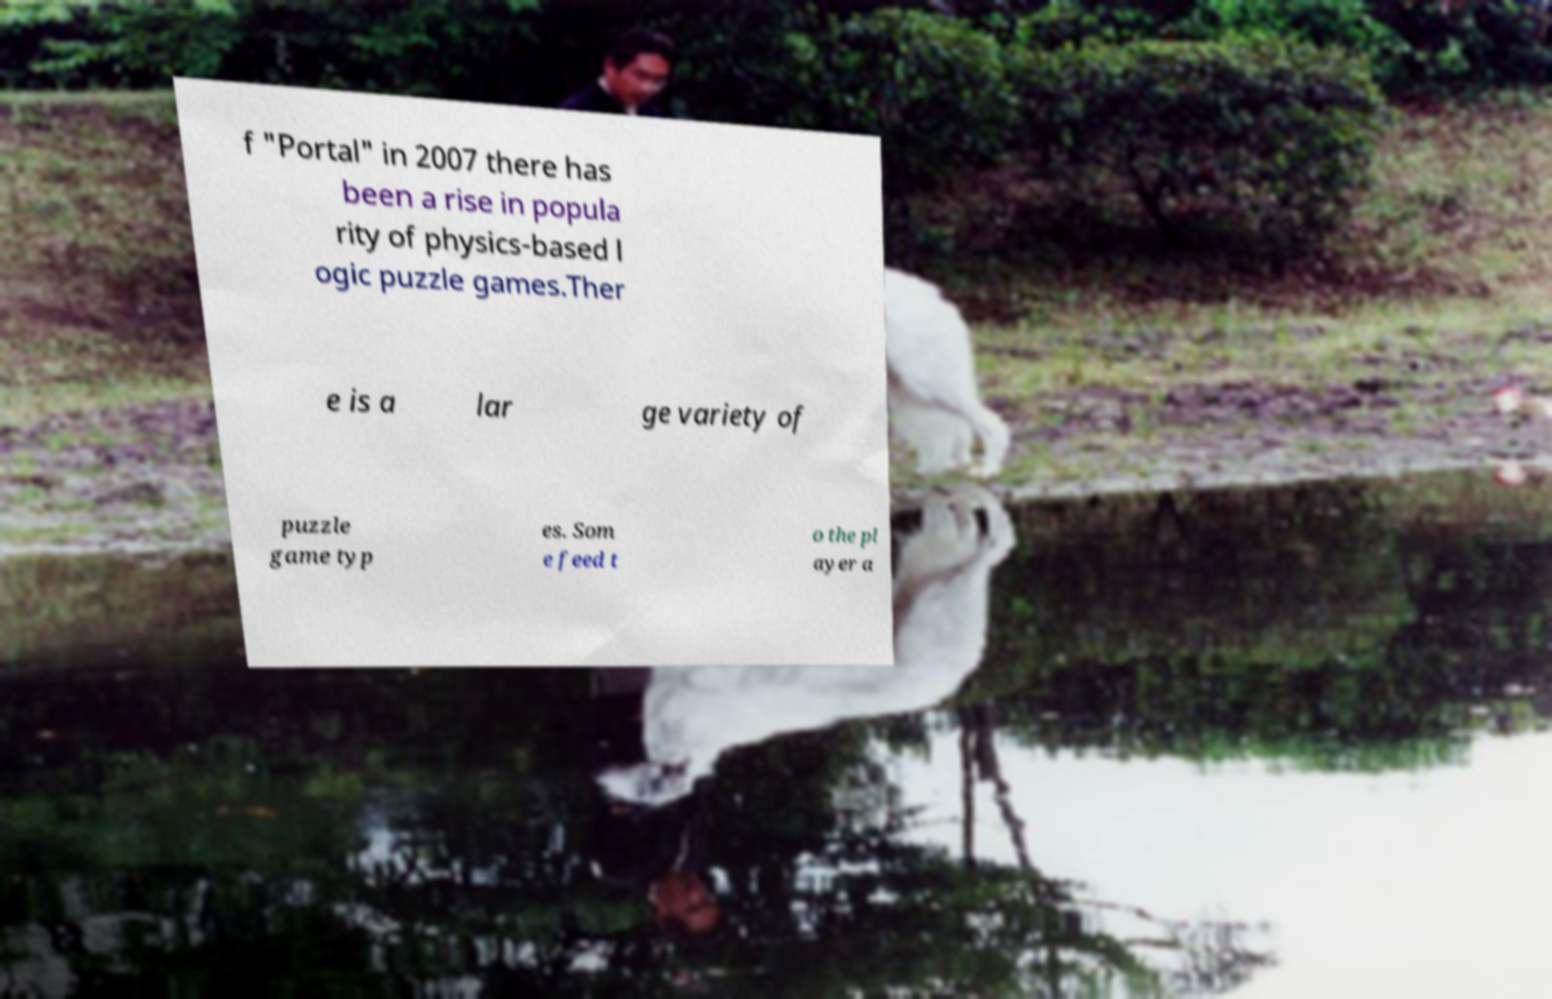Can you accurately transcribe the text from the provided image for me? f "Portal" in 2007 there has been a rise in popula rity of physics-based l ogic puzzle games.Ther e is a lar ge variety of puzzle game typ es. Som e feed t o the pl ayer a 